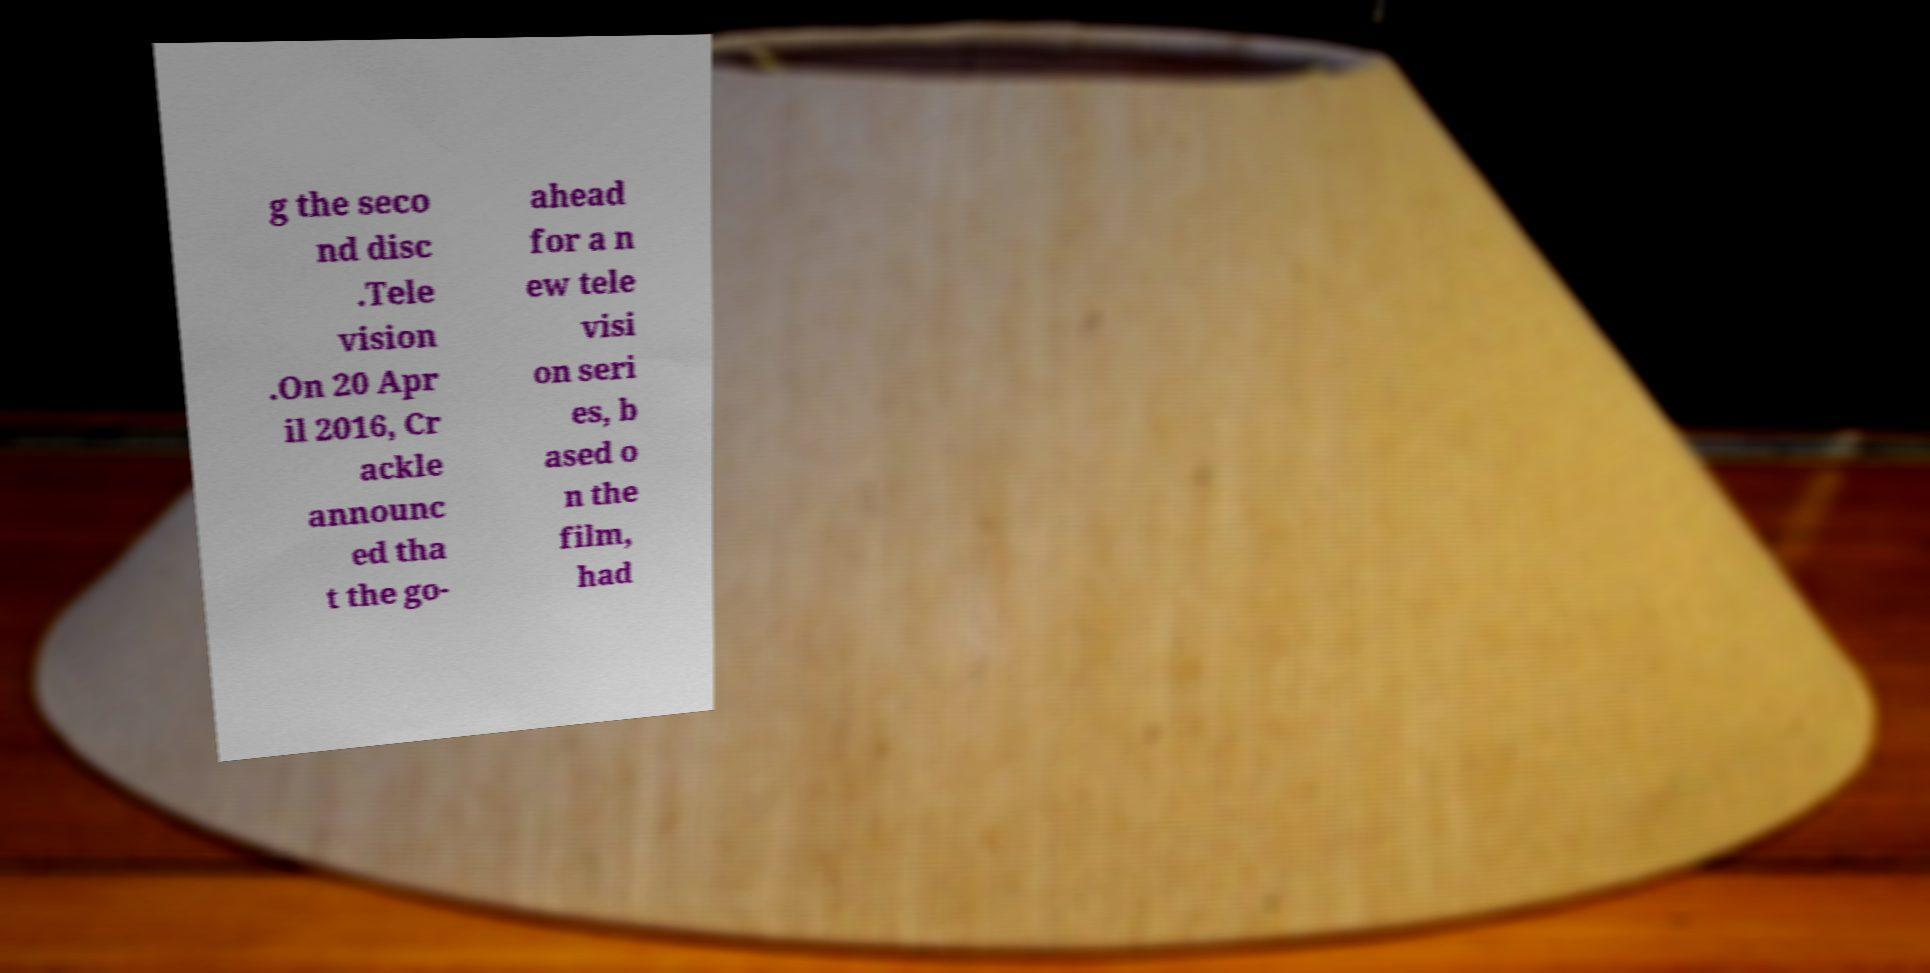There's text embedded in this image that I need extracted. Can you transcribe it verbatim? g the seco nd disc .Tele vision .On 20 Apr il 2016, Cr ackle announc ed tha t the go- ahead for a n ew tele visi on seri es, b ased o n the film, had 